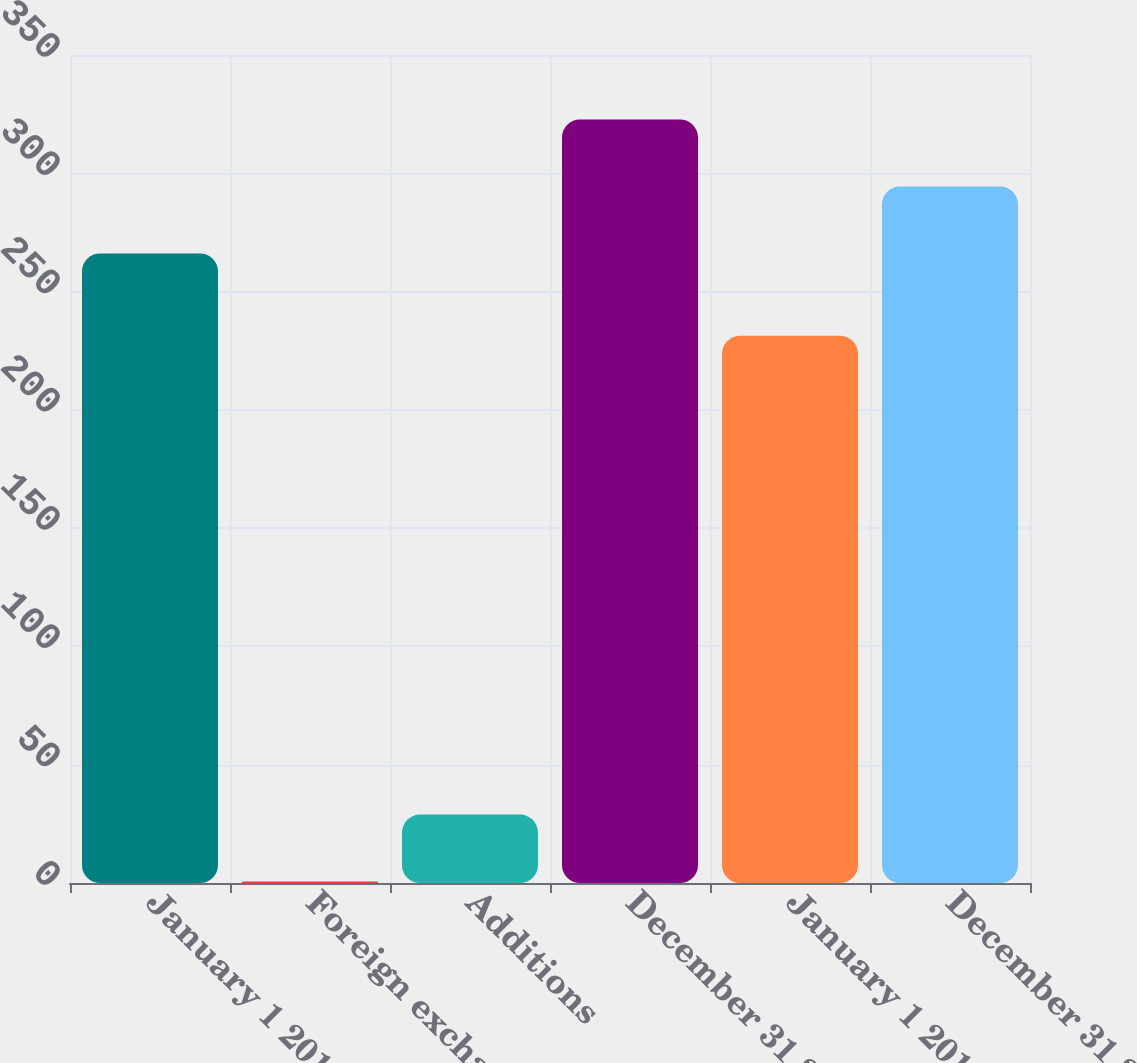Convert chart to OTSL. <chart><loc_0><loc_0><loc_500><loc_500><bar_chart><fcel>January 1 2011<fcel>Foreign exchange<fcel>Additions<fcel>December 31 2011<fcel>January 1 2010<fcel>December 31 2010<nl><fcel>266.1<fcel>0.6<fcel>28.94<fcel>322.78<fcel>231.3<fcel>294.44<nl></chart> 